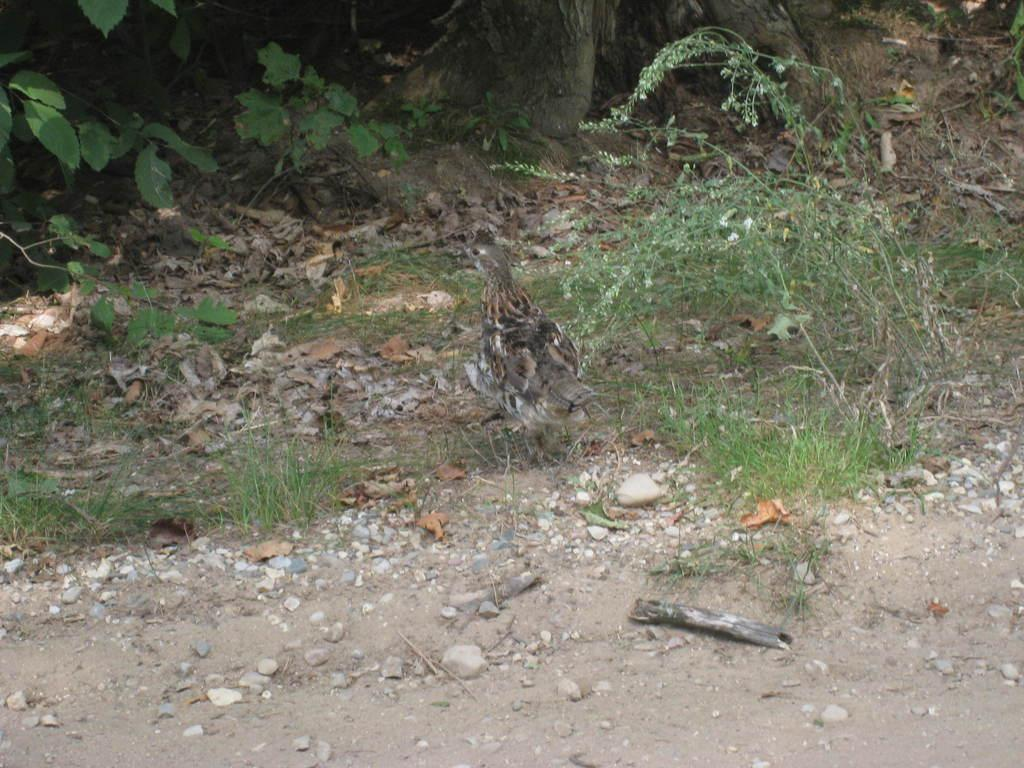What type of animal is in the image? There is a bird in the image. What colors can be seen on the bird? The bird has black and brown colors. What can be seen in the background of the image? There are plants in the background of the image. What color are the plants? The plants are green in color. What type of tool does the bird use to build its nest in the image? The image does not show the bird building a nest or using any tools, so it is not possible to answer that question. 